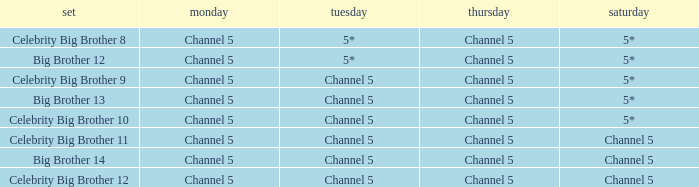Which series airs Saturday on Channel 5? Celebrity Big Brother 11, Big Brother 14, Celebrity Big Brother 12. 